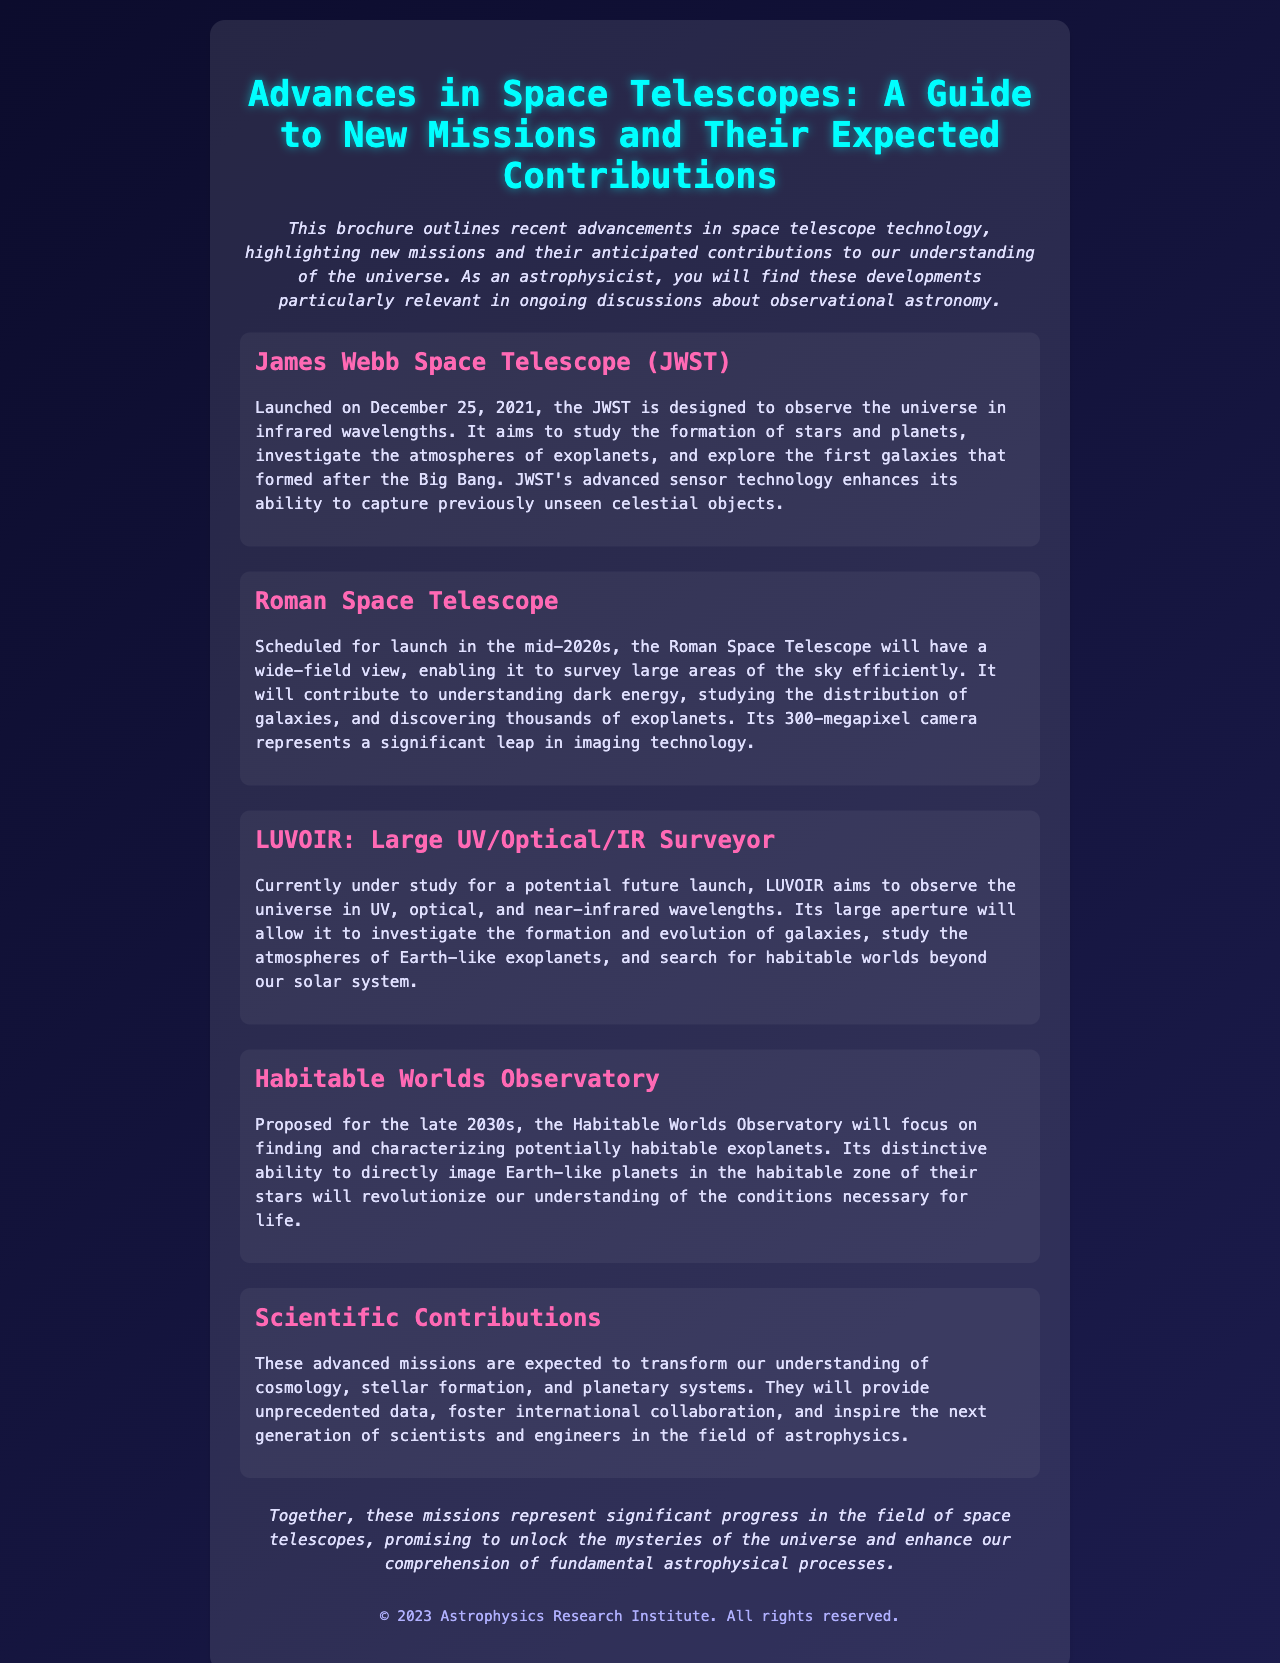what is the launch date of the JWST? The JWST was launched on December 25, 2021.
Answer: December 25, 2021 what is the primary focus of the Habitable Worlds Observatory? The Habitable Worlds Observatory focuses on finding and characterizing potentially habitable exoplanets.
Answer: Finding and characterizing potentially habitable exoplanets how many megapixels does the Roman Space Telescope's camera have? The Roman Space Telescope has a 300-megapixel camera.
Answer: 300-megapixels which space telescope is designed to observe the universe in infrared wavelengths? The James Webb Space Telescope (JWST) is designed for this purpose.
Answer: James Webb Space Telescope (JWST) what is one of the anticipated contributions of the LUVOIR mission? LUVOIR aims to study the atmospheres of Earth-like exoplanets.
Answer: Study the atmospheres of Earth-like exoplanets what era does the JWST aim to investigate regarding galaxies? JWST aims to explore the first galaxies that formed after the Big Bang.
Answer: The first galaxies that formed after the Big Bang which telescope will contribute to understanding dark energy? The Roman Space Telescope will contribute to this understanding.
Answer: Roman Space Telescope when is the scheduled launch for the Roman Space Telescope? The Roman Space Telescope is scheduled for launch in the mid-2020s.
Answer: Mid-2020s what will the advanced missions foster according to the document? The advanced missions will foster international collaboration.
Answer: International collaboration 